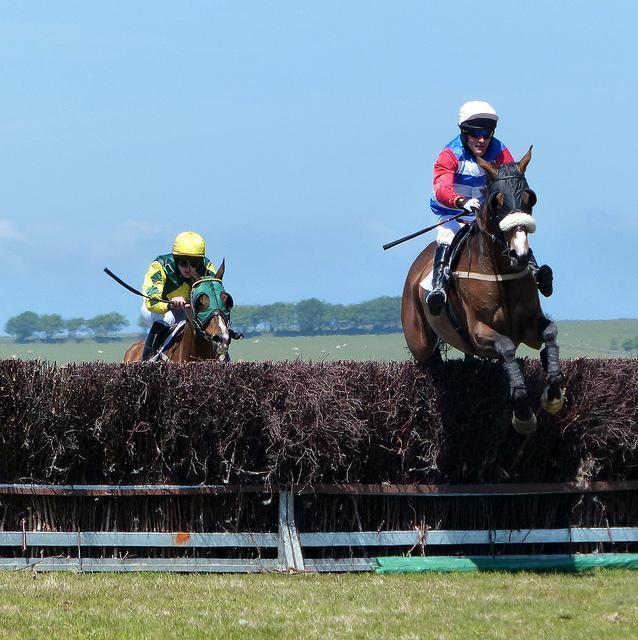How many horses are there?
Give a very brief answer. 2. How many people are there?
Give a very brief answer. 2. How many umbrellas are in this picture with the train?
Give a very brief answer. 0. 